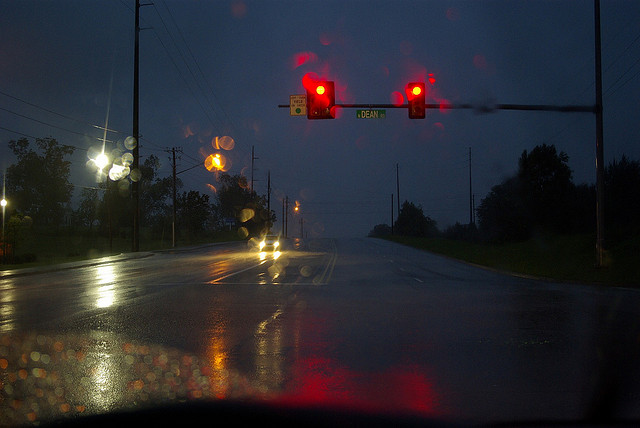Identify and read out the text in this image. OEAN 